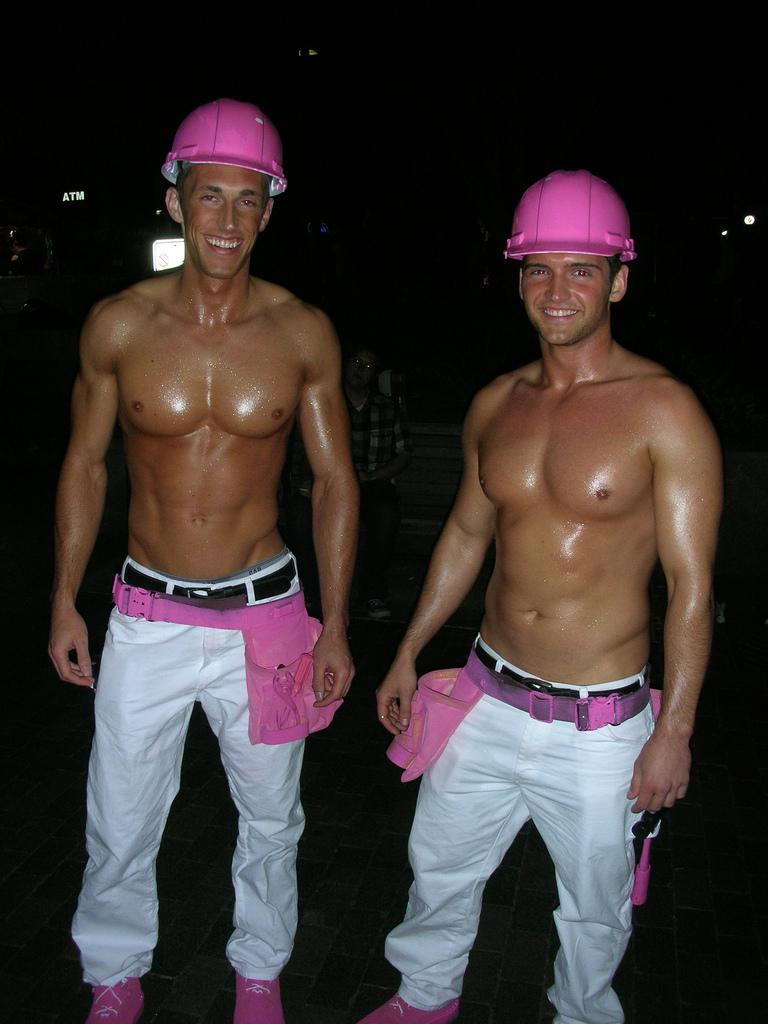How many people are in the image? There are three people in the image: two persons standing and smiling, and one person sitting. What are the people in the image doing? The people are standing, smiling, and sitting. What can be seen in the image besides the people? There are lights visible in the image. What is the color of the background in the image? The background of the image is dark. What type of land can be seen in the image? There is no land visible in the image; it features people and lights. What force is being applied to the person sitting in the image? There is no force being applied to the person sitting in the image; they are simply sitting. 